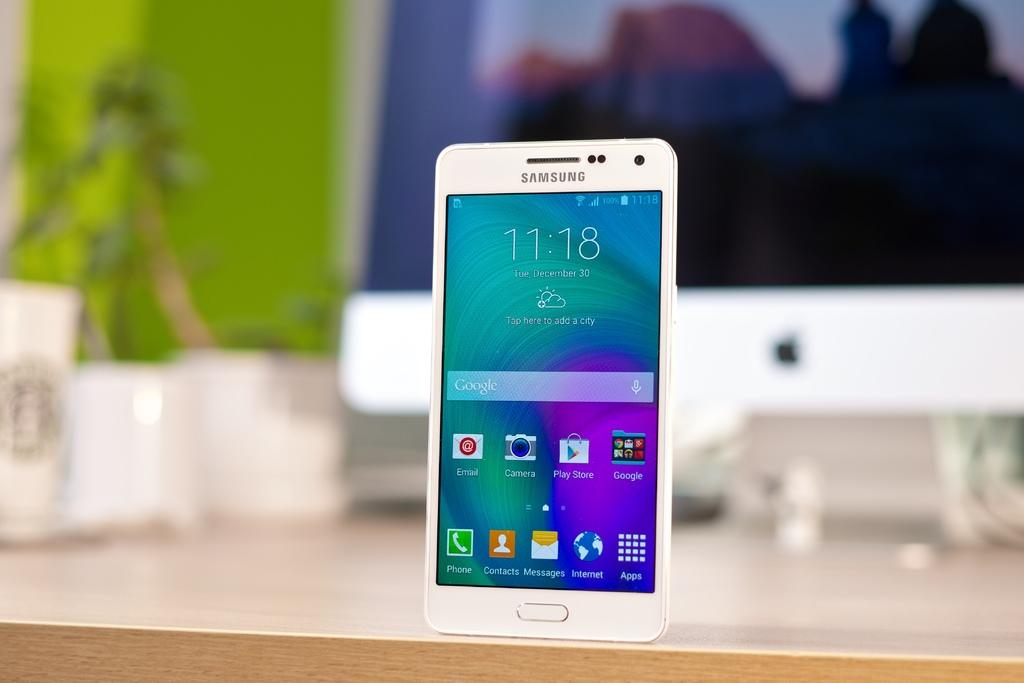What object is the main focus of the image? There is a mobile in the image. Where is the mobile located? The mobile is on a wooden desk. Can you describe the background of the image? The background of the image is blurred. What book is being read by the person in the image? There is no person present in the image, and therefore no book being read. What type of thunder can be heard in the background of the image? There is no sound in the image, and therefore no thunder can be heard. 